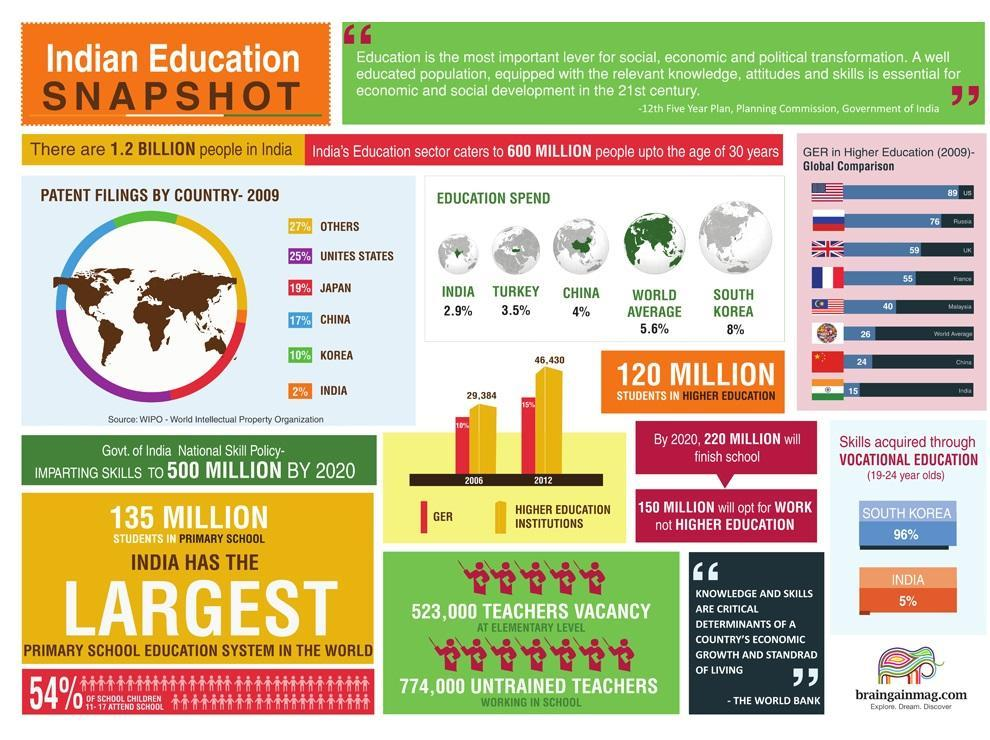What % of students in 19-24 years old, acquire skills through vocational education in India
Answer the question with a short phrase. 5% What % of students in 19-24 years old, acquire skills through vocational education in SOuth Korea 96% Which country has the second highest patents filed? Japan What is percentage of education spend of China, 2.9%, 3.5%, or 4%? 4% What is percentile gap in skills acquired through vocational education in South Korea and India? 91% What is the total % of patents filed by Japan, China and Korea 46 